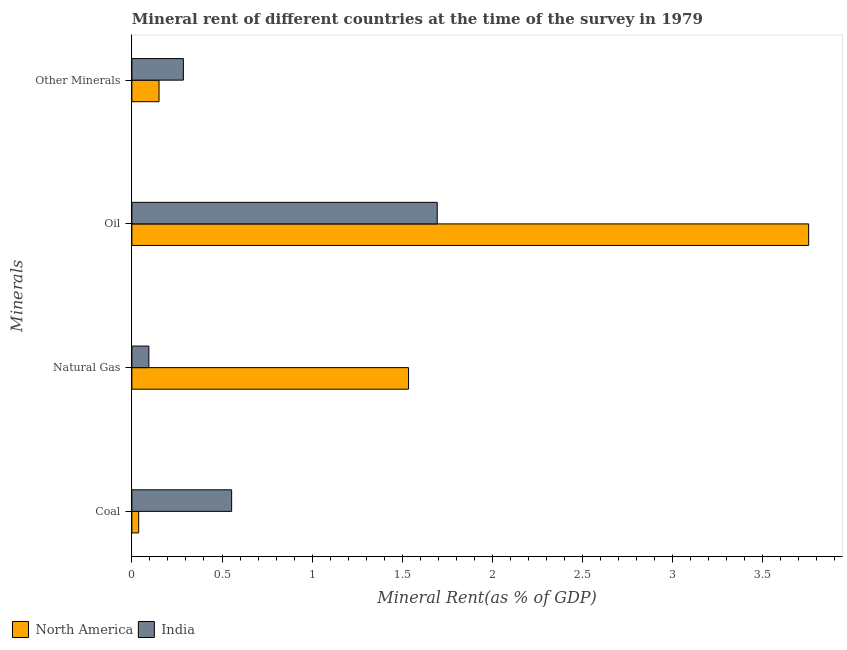How many bars are there on the 1st tick from the top?
Make the answer very short. 2. How many bars are there on the 2nd tick from the bottom?
Keep it short and to the point. 2. What is the label of the 1st group of bars from the top?
Give a very brief answer. Other Minerals. What is the coal rent in North America?
Your answer should be very brief. 0.04. Across all countries, what is the maximum  rent of other minerals?
Offer a terse response. 0.29. Across all countries, what is the minimum natural gas rent?
Your answer should be compact. 0.09. In which country was the oil rent maximum?
Your response must be concise. North America. In which country was the coal rent minimum?
Provide a short and direct response. North America. What is the total oil rent in the graph?
Keep it short and to the point. 5.45. What is the difference between the coal rent in North America and that in India?
Your answer should be compact. -0.52. What is the difference between the  rent of other minerals in India and the natural gas rent in North America?
Your response must be concise. -1.25. What is the average  rent of other minerals per country?
Offer a terse response. 0.22. What is the difference between the oil rent and natural gas rent in India?
Make the answer very short. 1.6. In how many countries, is the  rent of other minerals greater than 0.6 %?
Offer a very short reply. 0. What is the ratio of the oil rent in North America to that in India?
Your response must be concise. 2.22. Is the natural gas rent in India less than that in North America?
Your answer should be very brief. Yes. Is the difference between the  rent of other minerals in North America and India greater than the difference between the coal rent in North America and India?
Provide a succinct answer. Yes. What is the difference between the highest and the second highest coal rent?
Offer a very short reply. 0.52. What is the difference between the highest and the lowest natural gas rent?
Offer a very short reply. 1.44. Is the sum of the coal rent in North America and India greater than the maximum oil rent across all countries?
Your answer should be compact. No. What does the 1st bar from the top in Natural Gas represents?
Ensure brevity in your answer.  India. What does the 2nd bar from the bottom in Natural Gas represents?
Your answer should be compact. India. What is the difference between two consecutive major ticks on the X-axis?
Make the answer very short. 0.5. Does the graph contain any zero values?
Give a very brief answer. No. Does the graph contain grids?
Your answer should be compact. No. Where does the legend appear in the graph?
Your response must be concise. Bottom left. How many legend labels are there?
Give a very brief answer. 2. How are the legend labels stacked?
Your answer should be very brief. Horizontal. What is the title of the graph?
Your answer should be very brief. Mineral rent of different countries at the time of the survey in 1979. What is the label or title of the X-axis?
Your response must be concise. Mineral Rent(as % of GDP). What is the label or title of the Y-axis?
Your response must be concise. Minerals. What is the Mineral Rent(as % of GDP) in North America in Coal?
Offer a terse response. 0.04. What is the Mineral Rent(as % of GDP) of India in Coal?
Provide a succinct answer. 0.55. What is the Mineral Rent(as % of GDP) of North America in Natural Gas?
Provide a succinct answer. 1.53. What is the Mineral Rent(as % of GDP) in India in Natural Gas?
Offer a terse response. 0.09. What is the Mineral Rent(as % of GDP) in North America in Oil?
Give a very brief answer. 3.75. What is the Mineral Rent(as % of GDP) of India in Oil?
Ensure brevity in your answer.  1.69. What is the Mineral Rent(as % of GDP) of North America in Other Minerals?
Ensure brevity in your answer.  0.15. What is the Mineral Rent(as % of GDP) in India in Other Minerals?
Ensure brevity in your answer.  0.29. Across all Minerals, what is the maximum Mineral Rent(as % of GDP) of North America?
Provide a succinct answer. 3.75. Across all Minerals, what is the maximum Mineral Rent(as % of GDP) in India?
Keep it short and to the point. 1.69. Across all Minerals, what is the minimum Mineral Rent(as % of GDP) in North America?
Keep it short and to the point. 0.04. Across all Minerals, what is the minimum Mineral Rent(as % of GDP) in India?
Your response must be concise. 0.09. What is the total Mineral Rent(as % of GDP) of North America in the graph?
Offer a very short reply. 5.48. What is the total Mineral Rent(as % of GDP) in India in the graph?
Offer a very short reply. 2.63. What is the difference between the Mineral Rent(as % of GDP) in North America in Coal and that in Natural Gas?
Your answer should be compact. -1.5. What is the difference between the Mineral Rent(as % of GDP) of India in Coal and that in Natural Gas?
Your answer should be compact. 0.46. What is the difference between the Mineral Rent(as % of GDP) of North America in Coal and that in Oil?
Provide a short and direct response. -3.72. What is the difference between the Mineral Rent(as % of GDP) of India in Coal and that in Oil?
Your response must be concise. -1.14. What is the difference between the Mineral Rent(as % of GDP) in North America in Coal and that in Other Minerals?
Your response must be concise. -0.11. What is the difference between the Mineral Rent(as % of GDP) of India in Coal and that in Other Minerals?
Your answer should be compact. 0.27. What is the difference between the Mineral Rent(as % of GDP) in North America in Natural Gas and that in Oil?
Offer a terse response. -2.22. What is the difference between the Mineral Rent(as % of GDP) in India in Natural Gas and that in Oil?
Offer a terse response. -1.6. What is the difference between the Mineral Rent(as % of GDP) in North America in Natural Gas and that in Other Minerals?
Your answer should be compact. 1.38. What is the difference between the Mineral Rent(as % of GDP) of India in Natural Gas and that in Other Minerals?
Provide a succinct answer. -0.19. What is the difference between the Mineral Rent(as % of GDP) in North America in Oil and that in Other Minerals?
Your answer should be very brief. 3.6. What is the difference between the Mineral Rent(as % of GDP) in India in Oil and that in Other Minerals?
Your answer should be compact. 1.41. What is the difference between the Mineral Rent(as % of GDP) of North America in Coal and the Mineral Rent(as % of GDP) of India in Natural Gas?
Provide a short and direct response. -0.06. What is the difference between the Mineral Rent(as % of GDP) of North America in Coal and the Mineral Rent(as % of GDP) of India in Oil?
Your response must be concise. -1.66. What is the difference between the Mineral Rent(as % of GDP) of North America in Coal and the Mineral Rent(as % of GDP) of India in Other Minerals?
Make the answer very short. -0.25. What is the difference between the Mineral Rent(as % of GDP) of North America in Natural Gas and the Mineral Rent(as % of GDP) of India in Oil?
Give a very brief answer. -0.16. What is the difference between the Mineral Rent(as % of GDP) of North America in Natural Gas and the Mineral Rent(as % of GDP) of India in Other Minerals?
Your answer should be very brief. 1.25. What is the difference between the Mineral Rent(as % of GDP) of North America in Oil and the Mineral Rent(as % of GDP) of India in Other Minerals?
Offer a very short reply. 3.47. What is the average Mineral Rent(as % of GDP) of North America per Minerals?
Give a very brief answer. 1.37. What is the average Mineral Rent(as % of GDP) of India per Minerals?
Give a very brief answer. 0.66. What is the difference between the Mineral Rent(as % of GDP) in North America and Mineral Rent(as % of GDP) in India in Coal?
Offer a very short reply. -0.52. What is the difference between the Mineral Rent(as % of GDP) of North America and Mineral Rent(as % of GDP) of India in Natural Gas?
Your answer should be very brief. 1.44. What is the difference between the Mineral Rent(as % of GDP) in North America and Mineral Rent(as % of GDP) in India in Oil?
Offer a terse response. 2.06. What is the difference between the Mineral Rent(as % of GDP) in North America and Mineral Rent(as % of GDP) in India in Other Minerals?
Offer a terse response. -0.14. What is the ratio of the Mineral Rent(as % of GDP) of North America in Coal to that in Natural Gas?
Ensure brevity in your answer.  0.02. What is the ratio of the Mineral Rent(as % of GDP) of India in Coal to that in Natural Gas?
Your response must be concise. 5.87. What is the ratio of the Mineral Rent(as % of GDP) of North America in Coal to that in Oil?
Your answer should be compact. 0.01. What is the ratio of the Mineral Rent(as % of GDP) in India in Coal to that in Oil?
Provide a succinct answer. 0.33. What is the ratio of the Mineral Rent(as % of GDP) in North America in Coal to that in Other Minerals?
Ensure brevity in your answer.  0.25. What is the ratio of the Mineral Rent(as % of GDP) of India in Coal to that in Other Minerals?
Your answer should be very brief. 1.94. What is the ratio of the Mineral Rent(as % of GDP) of North America in Natural Gas to that in Oil?
Your answer should be compact. 0.41. What is the ratio of the Mineral Rent(as % of GDP) in India in Natural Gas to that in Oil?
Give a very brief answer. 0.06. What is the ratio of the Mineral Rent(as % of GDP) in North America in Natural Gas to that in Other Minerals?
Provide a succinct answer. 10.18. What is the ratio of the Mineral Rent(as % of GDP) of India in Natural Gas to that in Other Minerals?
Offer a very short reply. 0.33. What is the ratio of the Mineral Rent(as % of GDP) of North America in Oil to that in Other Minerals?
Provide a succinct answer. 24.91. What is the ratio of the Mineral Rent(as % of GDP) of India in Oil to that in Other Minerals?
Offer a terse response. 5.93. What is the difference between the highest and the second highest Mineral Rent(as % of GDP) of North America?
Provide a succinct answer. 2.22. What is the difference between the highest and the second highest Mineral Rent(as % of GDP) in India?
Your response must be concise. 1.14. What is the difference between the highest and the lowest Mineral Rent(as % of GDP) of North America?
Keep it short and to the point. 3.72. What is the difference between the highest and the lowest Mineral Rent(as % of GDP) in India?
Make the answer very short. 1.6. 